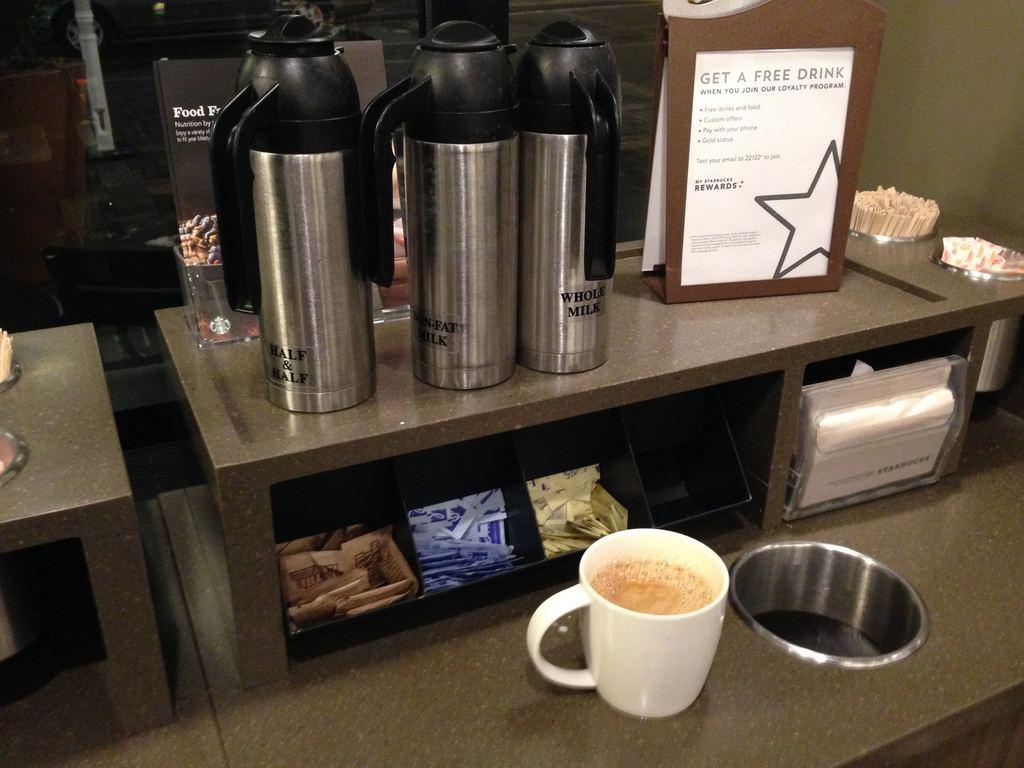<image>
Relay a brief, clear account of the picture shown. a white paper that says get a free drink 